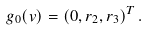Convert formula to latex. <formula><loc_0><loc_0><loc_500><loc_500>g _ { 0 } ( { v } ) = \left ( 0 , r _ { 2 } , r _ { 3 } \right ) ^ { T } .</formula> 